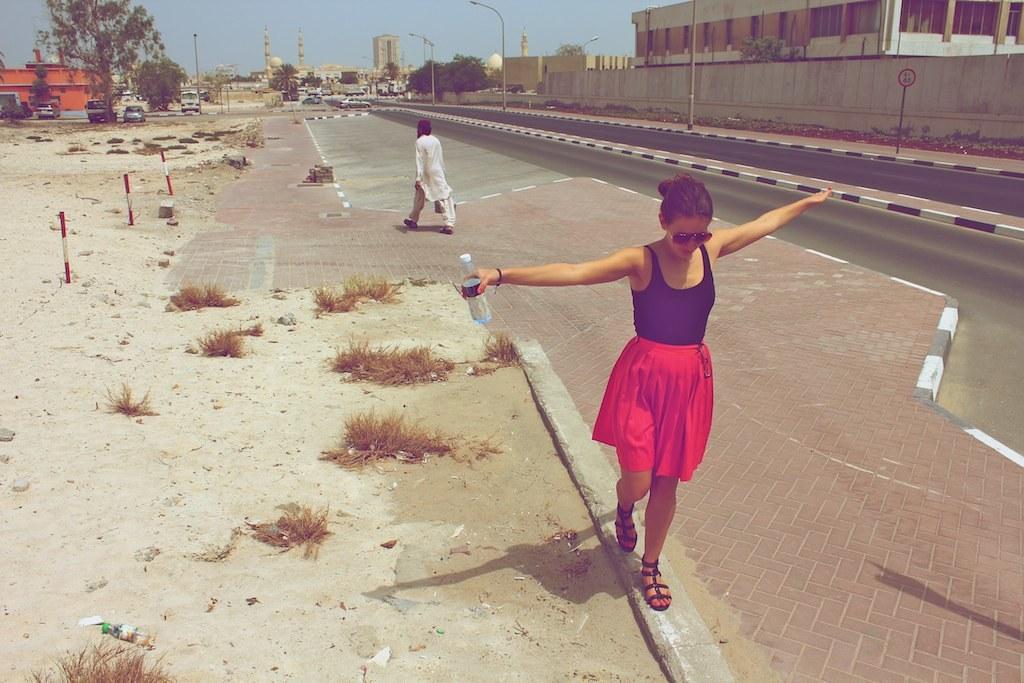Could you give a brief overview of what you see in this image? In this image I can see a person is holding a bottle. Back I can see one person is walking. Back I can see few buildings, wall, sign boards, poles, light poles, vehicles and trees. 